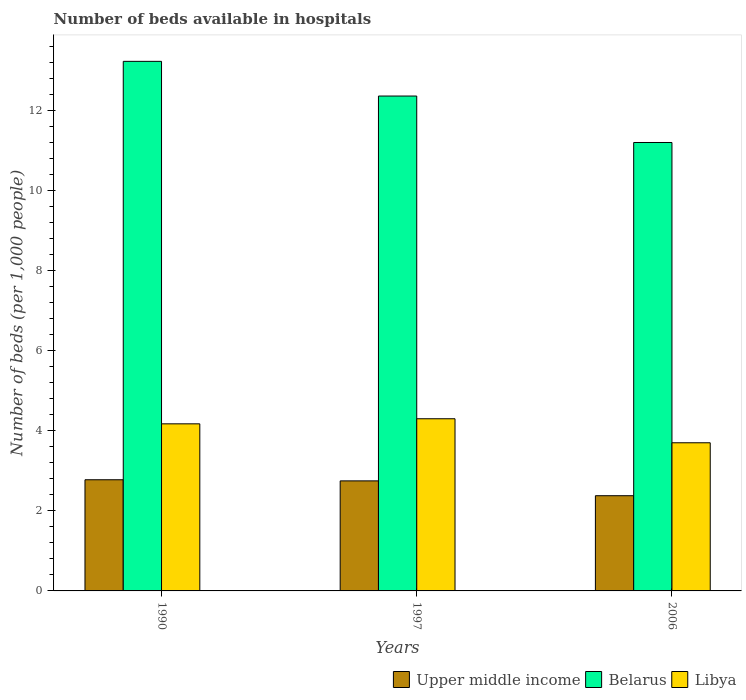How many groups of bars are there?
Provide a succinct answer. 3. Are the number of bars per tick equal to the number of legend labels?
Your answer should be very brief. Yes. How many bars are there on the 3rd tick from the left?
Offer a very short reply. 3. In how many cases, is the number of bars for a given year not equal to the number of legend labels?
Offer a very short reply. 0. Across all years, what is the maximum number of beds in the hospiatls of in Libya?
Your response must be concise. 4.3. In which year was the number of beds in the hospiatls of in Libya maximum?
Offer a terse response. 1997. What is the total number of beds in the hospiatls of in Upper middle income in the graph?
Provide a short and direct response. 7.9. What is the difference between the number of beds in the hospiatls of in Belarus in 1997 and that in 2006?
Your response must be concise. 1.16. What is the difference between the number of beds in the hospiatls of in Libya in 1997 and the number of beds in the hospiatls of in Upper middle income in 1990?
Keep it short and to the point. 1.52. What is the average number of beds in the hospiatls of in Libya per year?
Provide a succinct answer. 4.06. In the year 1990, what is the difference between the number of beds in the hospiatls of in Libya and number of beds in the hospiatls of in Upper middle income?
Your response must be concise. 1.4. What is the ratio of the number of beds in the hospiatls of in Upper middle income in 1997 to that in 2006?
Offer a very short reply. 1.16. What is the difference between the highest and the second highest number of beds in the hospiatls of in Upper middle income?
Provide a short and direct response. 0.03. What is the difference between the highest and the lowest number of beds in the hospiatls of in Libya?
Ensure brevity in your answer.  0.6. In how many years, is the number of beds in the hospiatls of in Belarus greater than the average number of beds in the hospiatls of in Belarus taken over all years?
Ensure brevity in your answer.  2. Is the sum of the number of beds in the hospiatls of in Belarus in 1997 and 2006 greater than the maximum number of beds in the hospiatls of in Libya across all years?
Your answer should be compact. Yes. What does the 3rd bar from the left in 1990 represents?
Make the answer very short. Libya. What does the 1st bar from the right in 1990 represents?
Ensure brevity in your answer.  Libya. Is it the case that in every year, the sum of the number of beds in the hospiatls of in Upper middle income and number of beds in the hospiatls of in Belarus is greater than the number of beds in the hospiatls of in Libya?
Your response must be concise. Yes. Are all the bars in the graph horizontal?
Your answer should be very brief. No. How many years are there in the graph?
Your answer should be compact. 3. Are the values on the major ticks of Y-axis written in scientific E-notation?
Provide a short and direct response. No. Does the graph contain any zero values?
Give a very brief answer. No. What is the title of the graph?
Keep it short and to the point. Number of beds available in hospitals. Does "Benin" appear as one of the legend labels in the graph?
Provide a succinct answer. No. What is the label or title of the Y-axis?
Ensure brevity in your answer.  Number of beds (per 1,0 people). What is the Number of beds (per 1,000 people) of Upper middle income in 1990?
Offer a terse response. 2.78. What is the Number of beds (per 1,000 people) of Belarus in 1990?
Your response must be concise. 13.23. What is the Number of beds (per 1,000 people) of Libya in 1990?
Offer a very short reply. 4.17. What is the Number of beds (per 1,000 people) of Upper middle income in 1997?
Your response must be concise. 2.75. What is the Number of beds (per 1,000 people) of Belarus in 1997?
Provide a short and direct response. 12.36. What is the Number of beds (per 1,000 people) of Libya in 1997?
Your answer should be compact. 4.3. What is the Number of beds (per 1,000 people) of Upper middle income in 2006?
Your response must be concise. 2.38. What is the Number of beds (per 1,000 people) in Belarus in 2006?
Offer a terse response. 11.2. Across all years, what is the maximum Number of beds (per 1,000 people) in Upper middle income?
Offer a terse response. 2.78. Across all years, what is the maximum Number of beds (per 1,000 people) in Belarus?
Your answer should be compact. 13.23. Across all years, what is the maximum Number of beds (per 1,000 people) of Libya?
Your answer should be very brief. 4.3. Across all years, what is the minimum Number of beds (per 1,000 people) in Upper middle income?
Your answer should be compact. 2.38. Across all years, what is the minimum Number of beds (per 1,000 people) in Libya?
Your answer should be very brief. 3.7. What is the total Number of beds (per 1,000 people) of Upper middle income in the graph?
Make the answer very short. 7.9. What is the total Number of beds (per 1,000 people) in Belarus in the graph?
Offer a terse response. 36.79. What is the total Number of beds (per 1,000 people) of Libya in the graph?
Your response must be concise. 12.17. What is the difference between the Number of beds (per 1,000 people) in Upper middle income in 1990 and that in 1997?
Offer a very short reply. 0.03. What is the difference between the Number of beds (per 1,000 people) of Belarus in 1990 and that in 1997?
Ensure brevity in your answer.  0.87. What is the difference between the Number of beds (per 1,000 people) of Libya in 1990 and that in 1997?
Keep it short and to the point. -0.13. What is the difference between the Number of beds (per 1,000 people) in Upper middle income in 1990 and that in 2006?
Your answer should be very brief. 0.4. What is the difference between the Number of beds (per 1,000 people) in Belarus in 1990 and that in 2006?
Make the answer very short. 2.03. What is the difference between the Number of beds (per 1,000 people) of Libya in 1990 and that in 2006?
Make the answer very short. 0.47. What is the difference between the Number of beds (per 1,000 people) of Upper middle income in 1997 and that in 2006?
Your answer should be compact. 0.37. What is the difference between the Number of beds (per 1,000 people) in Belarus in 1997 and that in 2006?
Give a very brief answer. 1.16. What is the difference between the Number of beds (per 1,000 people) of Libya in 1997 and that in 2006?
Your answer should be very brief. 0.6. What is the difference between the Number of beds (per 1,000 people) in Upper middle income in 1990 and the Number of beds (per 1,000 people) in Belarus in 1997?
Your response must be concise. -9.58. What is the difference between the Number of beds (per 1,000 people) of Upper middle income in 1990 and the Number of beds (per 1,000 people) of Libya in 1997?
Offer a terse response. -1.52. What is the difference between the Number of beds (per 1,000 people) in Belarus in 1990 and the Number of beds (per 1,000 people) in Libya in 1997?
Your response must be concise. 8.93. What is the difference between the Number of beds (per 1,000 people) in Upper middle income in 1990 and the Number of beds (per 1,000 people) in Belarus in 2006?
Give a very brief answer. -8.42. What is the difference between the Number of beds (per 1,000 people) in Upper middle income in 1990 and the Number of beds (per 1,000 people) in Libya in 2006?
Make the answer very short. -0.92. What is the difference between the Number of beds (per 1,000 people) of Belarus in 1990 and the Number of beds (per 1,000 people) of Libya in 2006?
Offer a very short reply. 9.53. What is the difference between the Number of beds (per 1,000 people) in Upper middle income in 1997 and the Number of beds (per 1,000 people) in Belarus in 2006?
Make the answer very short. -8.45. What is the difference between the Number of beds (per 1,000 people) in Upper middle income in 1997 and the Number of beds (per 1,000 people) in Libya in 2006?
Your answer should be compact. -0.95. What is the difference between the Number of beds (per 1,000 people) of Belarus in 1997 and the Number of beds (per 1,000 people) of Libya in 2006?
Your response must be concise. 8.66. What is the average Number of beds (per 1,000 people) of Upper middle income per year?
Your answer should be compact. 2.63. What is the average Number of beds (per 1,000 people) in Belarus per year?
Offer a very short reply. 12.26. What is the average Number of beds (per 1,000 people) in Libya per year?
Give a very brief answer. 4.06. In the year 1990, what is the difference between the Number of beds (per 1,000 people) of Upper middle income and Number of beds (per 1,000 people) of Belarus?
Offer a terse response. -10.45. In the year 1990, what is the difference between the Number of beds (per 1,000 people) in Upper middle income and Number of beds (per 1,000 people) in Libya?
Keep it short and to the point. -1.4. In the year 1990, what is the difference between the Number of beds (per 1,000 people) of Belarus and Number of beds (per 1,000 people) of Libya?
Ensure brevity in your answer.  9.05. In the year 1997, what is the difference between the Number of beds (per 1,000 people) of Upper middle income and Number of beds (per 1,000 people) of Belarus?
Give a very brief answer. -9.61. In the year 1997, what is the difference between the Number of beds (per 1,000 people) in Upper middle income and Number of beds (per 1,000 people) in Libya?
Offer a very short reply. -1.55. In the year 1997, what is the difference between the Number of beds (per 1,000 people) in Belarus and Number of beds (per 1,000 people) in Libya?
Give a very brief answer. 8.06. In the year 2006, what is the difference between the Number of beds (per 1,000 people) in Upper middle income and Number of beds (per 1,000 people) in Belarus?
Your response must be concise. -8.82. In the year 2006, what is the difference between the Number of beds (per 1,000 people) in Upper middle income and Number of beds (per 1,000 people) in Libya?
Your response must be concise. -1.32. In the year 2006, what is the difference between the Number of beds (per 1,000 people) in Belarus and Number of beds (per 1,000 people) in Libya?
Give a very brief answer. 7.5. What is the ratio of the Number of beds (per 1,000 people) in Upper middle income in 1990 to that in 1997?
Make the answer very short. 1.01. What is the ratio of the Number of beds (per 1,000 people) in Belarus in 1990 to that in 1997?
Ensure brevity in your answer.  1.07. What is the ratio of the Number of beds (per 1,000 people) of Libya in 1990 to that in 1997?
Keep it short and to the point. 0.97. What is the ratio of the Number of beds (per 1,000 people) in Upper middle income in 1990 to that in 2006?
Give a very brief answer. 1.17. What is the ratio of the Number of beds (per 1,000 people) of Belarus in 1990 to that in 2006?
Ensure brevity in your answer.  1.18. What is the ratio of the Number of beds (per 1,000 people) of Libya in 1990 to that in 2006?
Offer a terse response. 1.13. What is the ratio of the Number of beds (per 1,000 people) of Upper middle income in 1997 to that in 2006?
Ensure brevity in your answer.  1.16. What is the ratio of the Number of beds (per 1,000 people) in Belarus in 1997 to that in 2006?
Keep it short and to the point. 1.1. What is the ratio of the Number of beds (per 1,000 people) in Libya in 1997 to that in 2006?
Ensure brevity in your answer.  1.16. What is the difference between the highest and the second highest Number of beds (per 1,000 people) of Upper middle income?
Make the answer very short. 0.03. What is the difference between the highest and the second highest Number of beds (per 1,000 people) in Belarus?
Give a very brief answer. 0.87. What is the difference between the highest and the second highest Number of beds (per 1,000 people) in Libya?
Your answer should be very brief. 0.13. What is the difference between the highest and the lowest Number of beds (per 1,000 people) of Upper middle income?
Your answer should be compact. 0.4. What is the difference between the highest and the lowest Number of beds (per 1,000 people) in Belarus?
Your response must be concise. 2.03. 